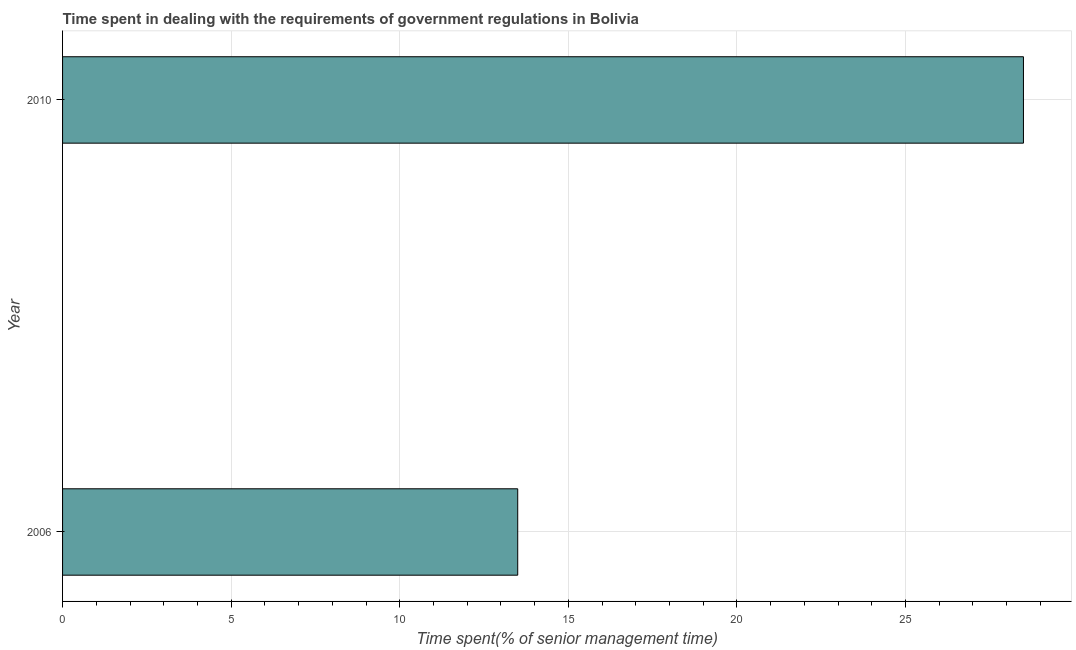What is the title of the graph?
Ensure brevity in your answer.  Time spent in dealing with the requirements of government regulations in Bolivia. What is the label or title of the X-axis?
Make the answer very short. Time spent(% of senior management time). What is the time spent in dealing with government regulations in 2010?
Offer a terse response. 28.5. Across all years, what is the minimum time spent in dealing with government regulations?
Offer a very short reply. 13.5. In which year was the time spent in dealing with government regulations maximum?
Make the answer very short. 2010. In which year was the time spent in dealing with government regulations minimum?
Your answer should be compact. 2006. What is the sum of the time spent in dealing with government regulations?
Give a very brief answer. 42. What is the difference between the time spent in dealing with government regulations in 2006 and 2010?
Keep it short and to the point. -15. What is the average time spent in dealing with government regulations per year?
Offer a terse response. 21. In how many years, is the time spent in dealing with government regulations greater than 2 %?
Offer a terse response. 2. What is the ratio of the time spent in dealing with government regulations in 2006 to that in 2010?
Give a very brief answer. 0.47. In how many years, is the time spent in dealing with government regulations greater than the average time spent in dealing with government regulations taken over all years?
Your answer should be very brief. 1. How many years are there in the graph?
Keep it short and to the point. 2. Are the values on the major ticks of X-axis written in scientific E-notation?
Provide a succinct answer. No. What is the Time spent(% of senior management time) in 2010?
Offer a terse response. 28.5. What is the difference between the Time spent(% of senior management time) in 2006 and 2010?
Your response must be concise. -15. What is the ratio of the Time spent(% of senior management time) in 2006 to that in 2010?
Offer a very short reply. 0.47. 